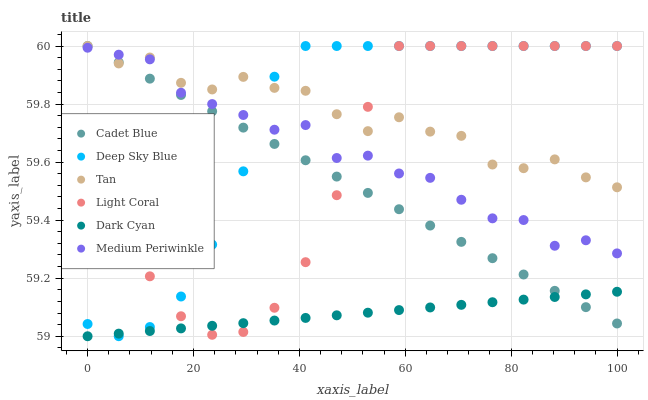Does Dark Cyan have the minimum area under the curve?
Answer yes or no. Yes. Does Tan have the maximum area under the curve?
Answer yes or no. Yes. Does Medium Periwinkle have the minimum area under the curve?
Answer yes or no. No. Does Medium Periwinkle have the maximum area under the curve?
Answer yes or no. No. Is Cadet Blue the smoothest?
Answer yes or no. Yes. Is Tan the roughest?
Answer yes or no. Yes. Is Medium Periwinkle the smoothest?
Answer yes or no. No. Is Medium Periwinkle the roughest?
Answer yes or no. No. Does Dark Cyan have the lowest value?
Answer yes or no. Yes. Does Medium Periwinkle have the lowest value?
Answer yes or no. No. Does Tan have the highest value?
Answer yes or no. Yes. Does Medium Periwinkle have the highest value?
Answer yes or no. No. Is Dark Cyan less than Tan?
Answer yes or no. Yes. Is Medium Periwinkle greater than Dark Cyan?
Answer yes or no. Yes. Does Light Coral intersect Medium Periwinkle?
Answer yes or no. Yes. Is Light Coral less than Medium Periwinkle?
Answer yes or no. No. Is Light Coral greater than Medium Periwinkle?
Answer yes or no. No. Does Dark Cyan intersect Tan?
Answer yes or no. No. 